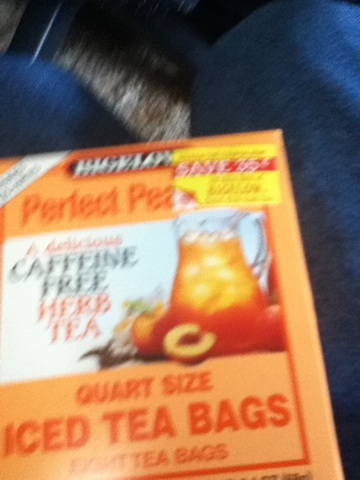Can you describe the main features of this product for me? Certainly! The product is a box of Perfect Peach iced tea bags, specifically in quart size. It is designed to make a refreshing and delicious peach-flavored iced tea. The box is predominantly orange and features an image of a glass pitcher filled with iced tea and ice cubes. The product is caffeine-free and offers a great alternative for those who wish to enjoy a flavorful drink without caffeine. What makes this peach iced tea special compared to other iced teas? Perfect Peach iced tea is special because it provides a unique peach flavor that is both refreshing and delicious. Unlike many other iced teas that might contain caffeine, this one is completely caffeine-free, making it a suitable choice for individuals who are sensitive to caffeine or prefer to avoid it. Additionally, the product is designed for convenience with quart-sized tea bags, making it easy to prepare a larger batch of iced tea for gatherings or daily consumption. 